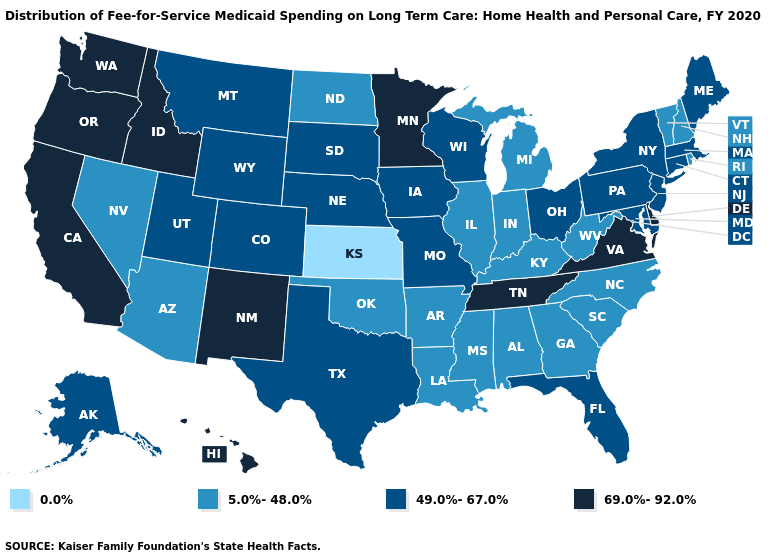Does Rhode Island have the highest value in the Northeast?
Quick response, please. No. What is the value of Florida?
Concise answer only. 49.0%-67.0%. What is the value of Delaware?
Quick response, please. 69.0%-92.0%. Name the states that have a value in the range 49.0%-67.0%?
Write a very short answer. Alaska, Colorado, Connecticut, Florida, Iowa, Maine, Maryland, Massachusetts, Missouri, Montana, Nebraska, New Jersey, New York, Ohio, Pennsylvania, South Dakota, Texas, Utah, Wisconsin, Wyoming. What is the value of Utah?
Keep it brief. 49.0%-67.0%. What is the lowest value in the USA?
Short answer required. 0.0%. What is the value of Idaho?
Write a very short answer. 69.0%-92.0%. Does the first symbol in the legend represent the smallest category?
Write a very short answer. Yes. Name the states that have a value in the range 49.0%-67.0%?
Quick response, please. Alaska, Colorado, Connecticut, Florida, Iowa, Maine, Maryland, Massachusetts, Missouri, Montana, Nebraska, New Jersey, New York, Ohio, Pennsylvania, South Dakota, Texas, Utah, Wisconsin, Wyoming. What is the value of Missouri?
Quick response, please. 49.0%-67.0%. Is the legend a continuous bar?
Short answer required. No. Which states have the lowest value in the USA?
Keep it brief. Kansas. Does California have the highest value in the West?
Concise answer only. Yes. Which states hav the highest value in the MidWest?
Be succinct. Minnesota. Among the states that border Vermont , does Massachusetts have the lowest value?
Quick response, please. No. 